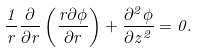Convert formula to latex. <formula><loc_0><loc_0><loc_500><loc_500>\frac { 1 } { r } \frac { \partial } { \partial r } \left ( \frac { r \partial \phi } { \partial r } \right ) + \frac { \partial ^ { 2 } \phi } { \partial z ^ { 2 } } = 0 .</formula> 